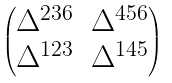Convert formula to latex. <formula><loc_0><loc_0><loc_500><loc_500>\begin{pmatrix} \Delta ^ { 2 3 6 } & \Delta ^ { 4 5 6 } \\ \Delta ^ { 1 2 3 } & \Delta ^ { 1 4 5 } \end{pmatrix}</formula> 